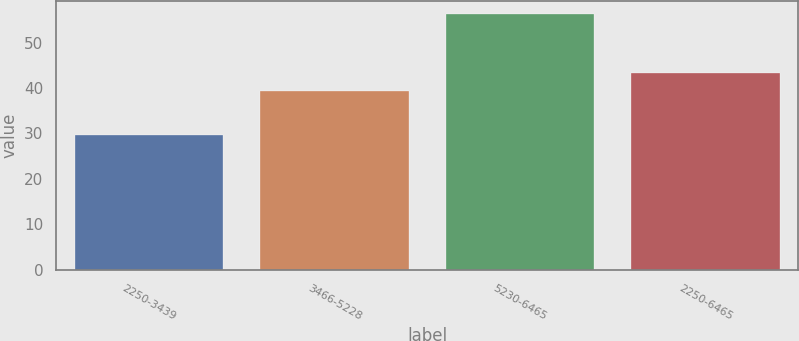Convert chart to OTSL. <chart><loc_0><loc_0><loc_500><loc_500><bar_chart><fcel>2250-3439<fcel>3466-5228<fcel>5230-6465<fcel>2250-6465<nl><fcel>29.64<fcel>39.33<fcel>56.37<fcel>43.26<nl></chart> 